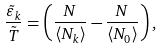<formula> <loc_0><loc_0><loc_500><loc_500>\frac { \tilde { \varepsilon } _ { k } } { \tilde { T } } = \left ( \frac { N } { \langle N _ { k } \rangle } - \frac { N } { \langle N _ { 0 } \rangle } \right ) ,</formula> 